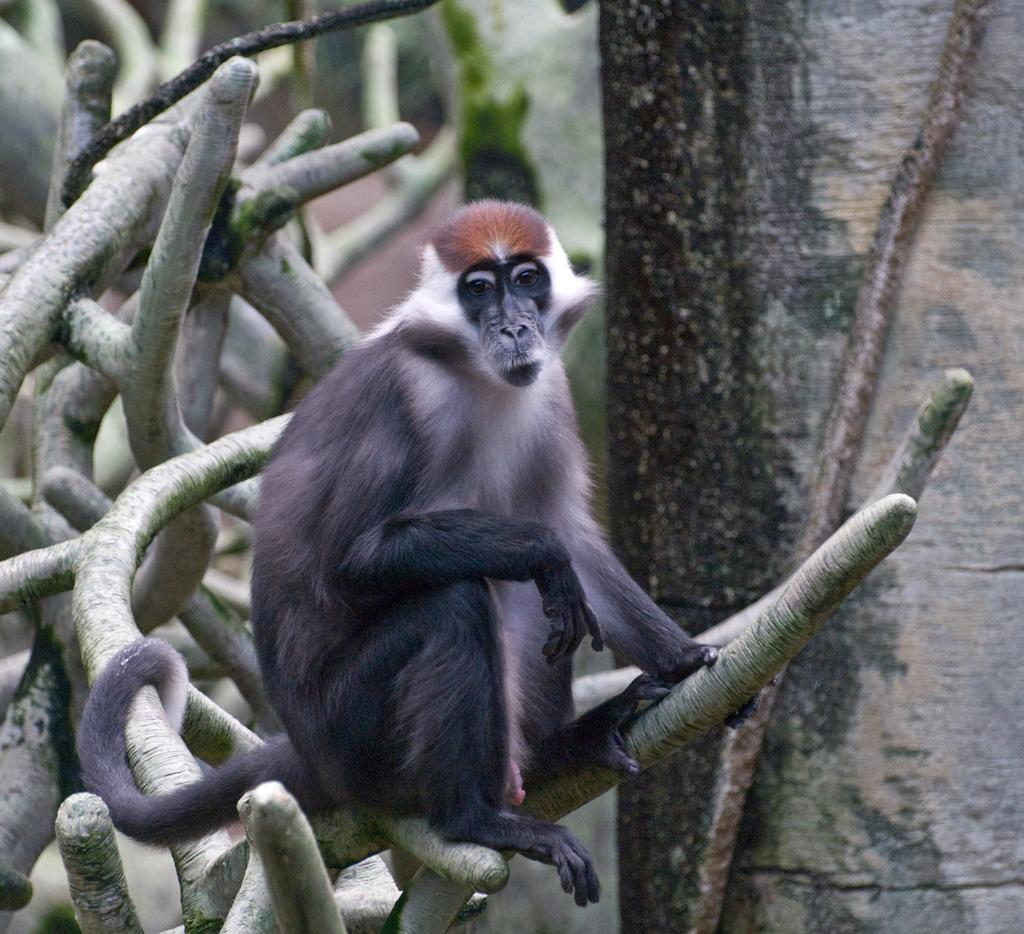What type of creature can be seen in the image? There is an animal in the image. Where is the animal located? The animal is on a tree. How many pigs are sleeping in the bushes in the image? There are no pigs or bushes present in the image; it features an animal on a tree. 